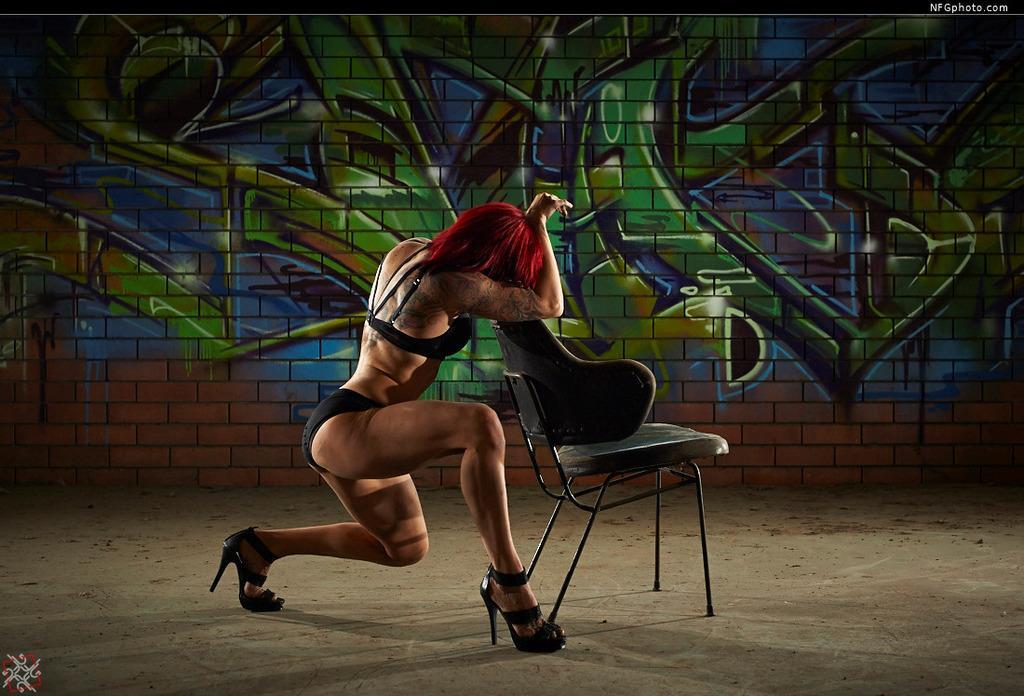In one or two sentences, can you explain what this image depicts? In this image a lady is there in front of her there is a chair. In the background on the wall there is graffiti. 